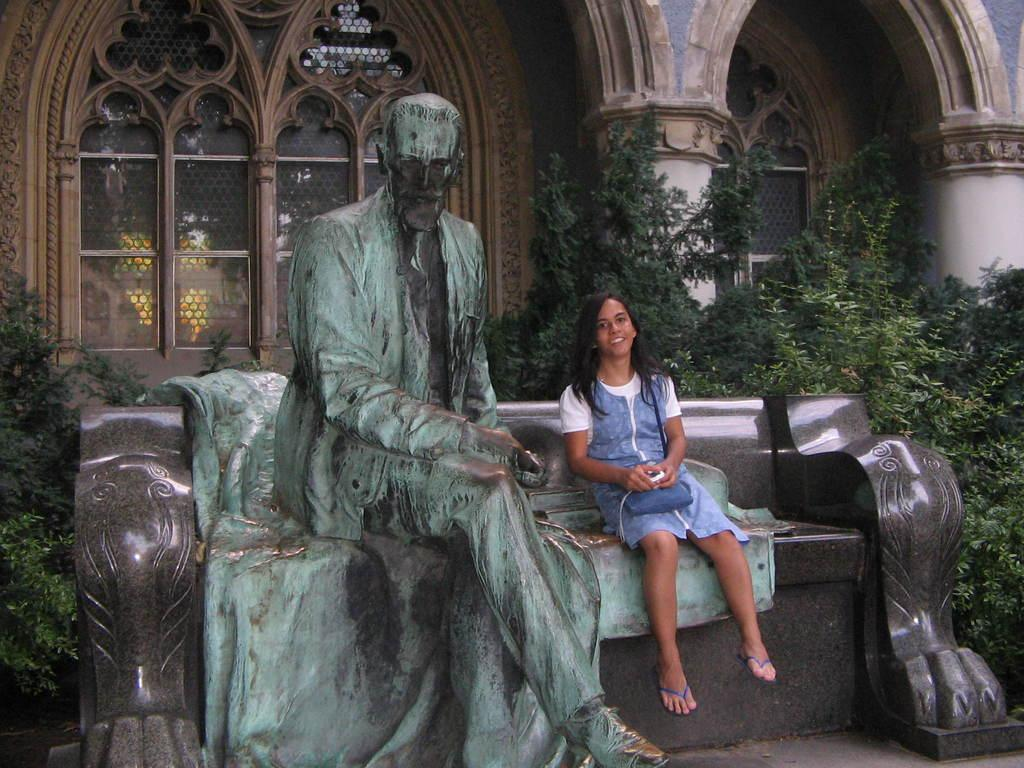What is the girl doing in the picture? The girl is sitting in the picture. Where is the girl sitting in relation to the sculpture? The girl is sitting beside a sculpture on a bench. What can be seen in the background of the image? There is a building visible in the background of the image. What type of natural elements can be seen in the image? There are trees visible in the image. Can you hear the girl whistling in the image? There is no indication in the image that the girl is whistling, so it cannot be determined from the picture. 